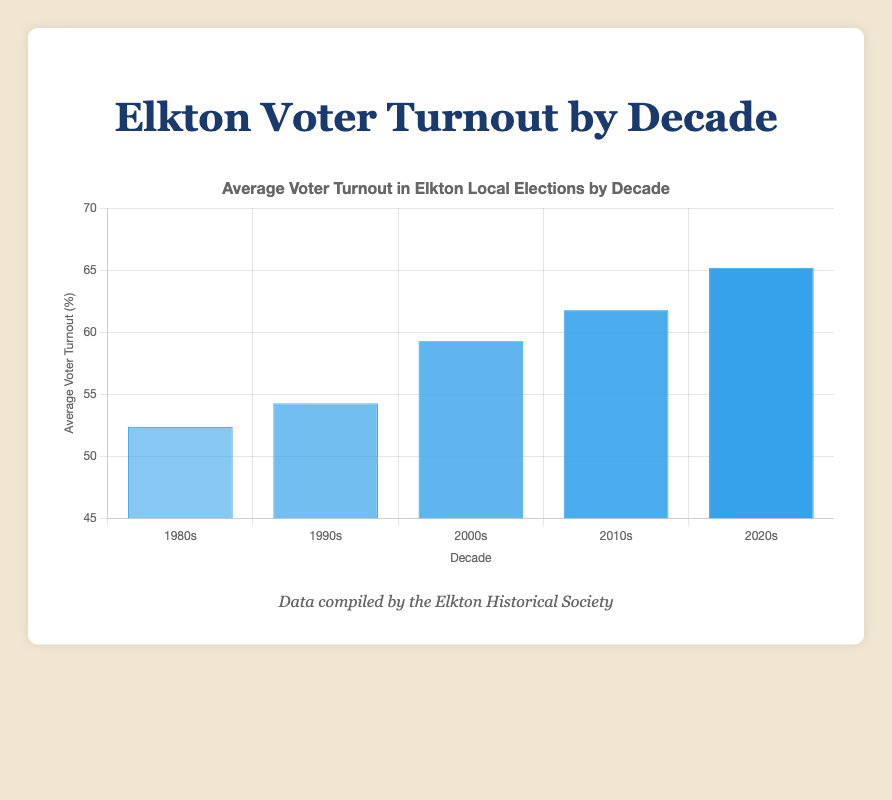What is the percentage difference in voter turnout between the 2010s and 2020s? Average turnout for the 2010s is approximately 61.78% and for the 2020s about 65.2%. The percentage difference is 65.2% - 61.78% = 3.42%.
Answer: 3.42% 